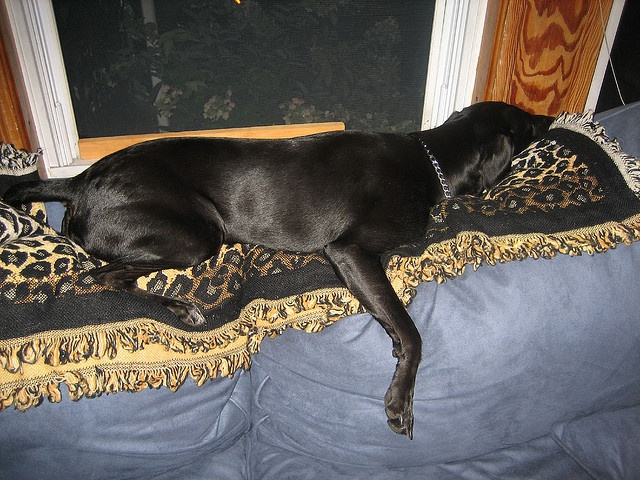Describe the objects in this image and their specific colors. I can see couch in maroon, darkgray, gray, and black tones and dog in maroon, black, and gray tones in this image. 